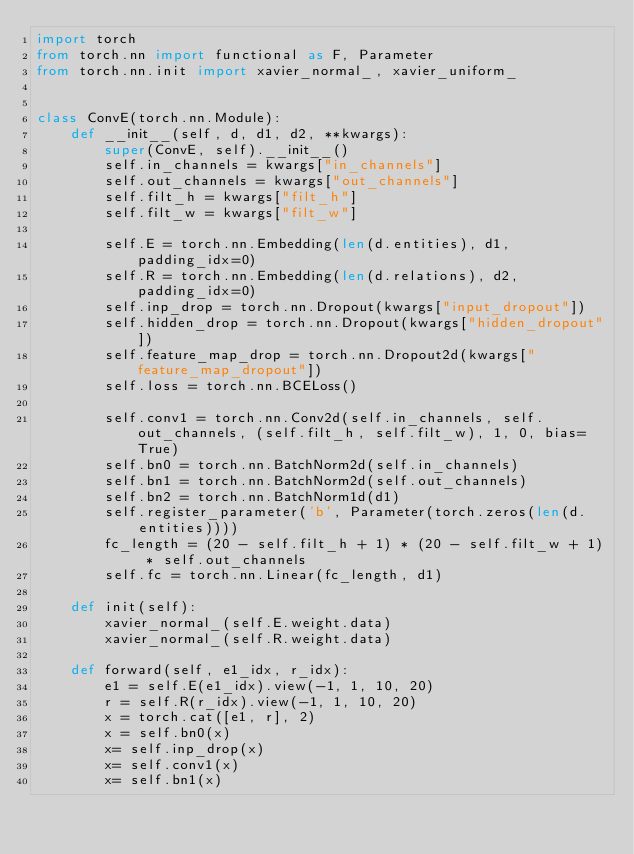<code> <loc_0><loc_0><loc_500><loc_500><_Python_>import torch
from torch.nn import functional as F, Parameter
from torch.nn.init import xavier_normal_, xavier_uniform_


class ConvE(torch.nn.Module):
    def __init__(self, d, d1, d2, **kwargs):
        super(ConvE, self).__init__()
        self.in_channels = kwargs["in_channels"]
        self.out_channels = kwargs["out_channels"]
        self.filt_h = kwargs["filt_h"]
        self.filt_w = kwargs["filt_w"]

        self.E = torch.nn.Embedding(len(d.entities), d1, padding_idx=0)
        self.R = torch.nn.Embedding(len(d.relations), d2, padding_idx=0)
        self.inp_drop = torch.nn.Dropout(kwargs["input_dropout"])
        self.hidden_drop = torch.nn.Dropout(kwargs["hidden_dropout"])
        self.feature_map_drop = torch.nn.Dropout2d(kwargs["feature_map_dropout"])
        self.loss = torch.nn.BCELoss()

        self.conv1 = torch.nn.Conv2d(self.in_channels, self.out_channels, (self.filt_h, self.filt_w), 1, 0, bias=True)
        self.bn0 = torch.nn.BatchNorm2d(self.in_channels)
        self.bn1 = torch.nn.BatchNorm2d(self.out_channels)
        self.bn2 = torch.nn.BatchNorm1d(d1)
        self.register_parameter('b', Parameter(torch.zeros(len(d.entities))))
        fc_length = (20 - self.filt_h + 1) * (20 - self.filt_w + 1) * self.out_channels
        self.fc = torch.nn.Linear(fc_length, d1)

    def init(self):
        xavier_normal_(self.E.weight.data)
        xavier_normal_(self.R.weight.data)

    def forward(self, e1_idx, r_idx):
        e1 = self.E(e1_idx).view(-1, 1, 10, 20)
        r = self.R(r_idx).view(-1, 1, 10, 20)
        x = torch.cat([e1, r], 2)
        x = self.bn0(x)
        x= self.inp_drop(x)
        x= self.conv1(x)
        x= self.bn1(x)</code> 